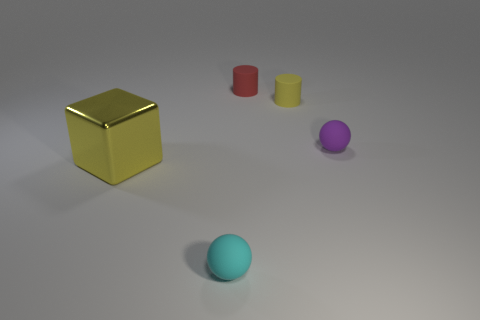There is a cylinder that is the same color as the big thing; what is its material?
Your answer should be compact. Rubber. There is a thing to the left of the small cyan rubber object; is its color the same as the rubber cylinder to the right of the tiny red object?
Provide a succinct answer. Yes. The other thing that is the same shape as the red rubber object is what color?
Ensure brevity in your answer.  Yellow. What material is the cyan thing?
Provide a succinct answer. Rubber. Is the number of rubber objects that are behind the metallic object greater than the number of small cyan rubber spheres?
Your response must be concise. Yes. There is a large cube that is on the left side of the yellow object behind the yellow metallic block; how many small purple spheres are in front of it?
Your response must be concise. 0. What is the material of the object that is both on the left side of the red rubber cylinder and behind the tiny cyan rubber sphere?
Make the answer very short. Metal. What color is the shiny thing?
Ensure brevity in your answer.  Yellow. Are there more purple rubber things left of the purple rubber object than blocks that are in front of the large block?
Keep it short and to the point. No. What is the color of the ball on the right side of the tiny cyan matte object?
Offer a terse response. Purple. 